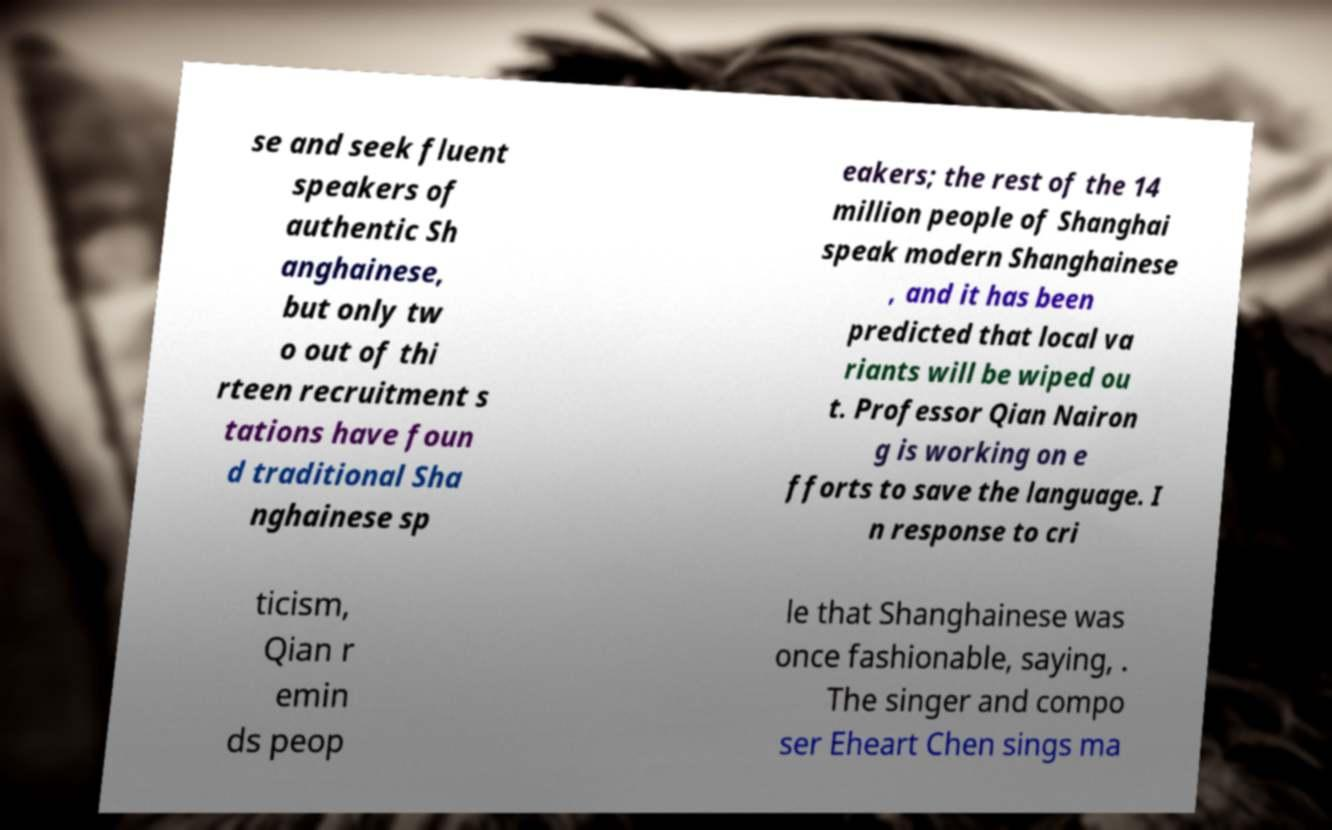Can you accurately transcribe the text from the provided image for me? se and seek fluent speakers of authentic Sh anghainese, but only tw o out of thi rteen recruitment s tations have foun d traditional Sha nghainese sp eakers; the rest of the 14 million people of Shanghai speak modern Shanghainese , and it has been predicted that local va riants will be wiped ou t. Professor Qian Nairon g is working on e fforts to save the language. I n response to cri ticism, Qian r emin ds peop le that Shanghainese was once fashionable, saying, . The singer and compo ser Eheart Chen sings ma 